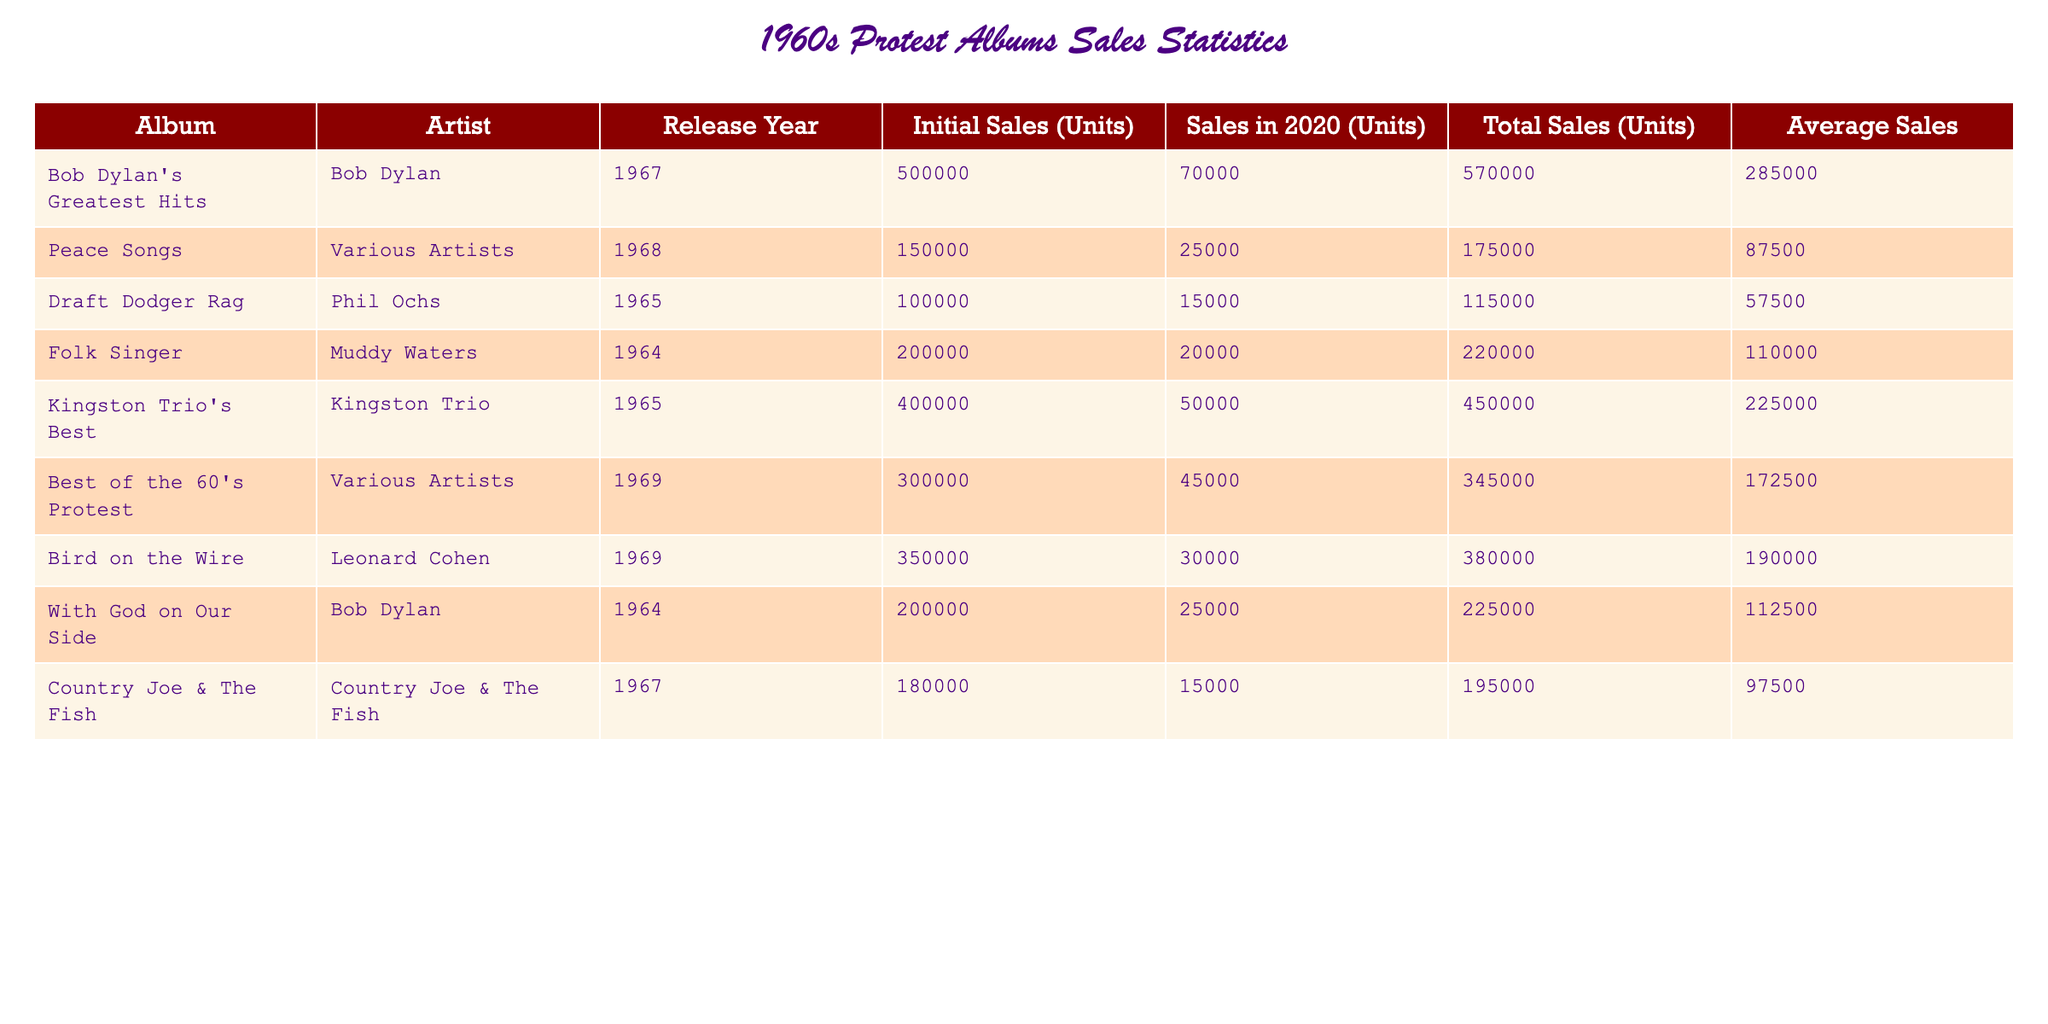What is the total sales for "Bob Dylan's Greatest Hits"? Referring to the table, the total sales for "Bob Dylan's Greatest Hits" is listed as 570,000 units.
Answer: 570000 Which album had the highest initial sales? The table shows that "Kingston Trio's Best" had the highest initial sales with 400,000 units, compared to other albums.
Answer: Kingston Trio's Best Is the average sales for "Draft Dodger Rag" greater than 100,000 units? To find the average sales for "Draft Dodger Rag," we calculate (100,000 + 15,000) / 2 = 57,500 units, which is less than 100,000.
Answer: No What is the difference in total sales between "Folk Singer" and "Country Joe & The Fish"? The total sales for "Folk Singer" is 220,000 units, and for "Country Joe & The Fish," it is 195,000 units. The difference is 220,000 - 195,000 = 25,000 units.
Answer: 25000 How many albums have total sales greater than 300,000 units? By examining the table, the albums that exceed 300,000 units in total sales are "Bob Dylan's Greatest Hits" (570,000), "Kingston Trio's Best" (450,000), and "Best of the 60's Protest" (345,000). Counting them gives us a total of 3 albums.
Answer: 3 What is the average total sales of all albums in the table? To find the average total sales, we sum all total sales values: 570,000 + 175,000 + 115,000 + 220,000 + 450,000 + 345,000 + 380,000 + 225,000 + 195,000 = 2,755,000 units. There are 9 albums, so the average is 2,755,000 / 9 = approximately 305,000 units.
Answer: 305000 Did "Bird on the Wire" have more sales in 2020 than "Peace Songs"? "Bird on the Wire" recorded sales of 30,000 units in 2020, while "Peace Songs" had 25,000 units. Since 30,000 is greater than 25,000, the statement is true.
Answer: Yes What is the combined initial sales of albums by Bob Dylan listed in the table? Bob Dylan's albums listed are "Bob Dylan's Greatest Hits" with 500,000 units and "With God on Our Side" with 200,000 units. Adding these gives 500,000 + 200,000 = 700,000 units in initial sales.
Answer: 700000 How many albums were released in 1965? From scrutinizing the table, the albums released in 1965 are "Draft Dodger Rag" and "Kingston Trio's Best." There are 2 albums released in that year.
Answer: 2 